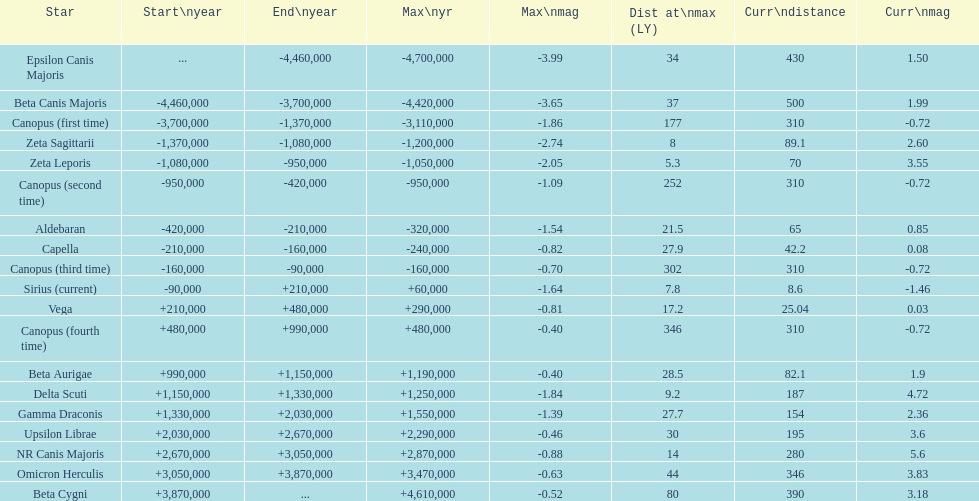Could you parse the entire table as a dict? {'header': ['Star', 'Start\\nyear', 'End\\nyear', 'Max\\nyr', 'Max\\nmag', 'Dist at\\nmax (LY)', 'Curr\\ndistance', 'Curr\\nmag'], 'rows': [['Epsilon Canis Majoris', '...', '-4,460,000', '-4,700,000', '-3.99', '34', '430', '1.50'], ['Beta Canis Majoris', '-4,460,000', '-3,700,000', '-4,420,000', '-3.65', '37', '500', '1.99'], ['Canopus (first time)', '-3,700,000', '-1,370,000', '-3,110,000', '-1.86', '177', '310', '-0.72'], ['Zeta Sagittarii', '-1,370,000', '-1,080,000', '-1,200,000', '-2.74', '8', '89.1', '2.60'], ['Zeta Leporis', '-1,080,000', '-950,000', '-1,050,000', '-2.05', '5.3', '70', '3.55'], ['Canopus (second time)', '-950,000', '-420,000', '-950,000', '-1.09', '252', '310', '-0.72'], ['Aldebaran', '-420,000', '-210,000', '-320,000', '-1.54', '21.5', '65', '0.85'], ['Capella', '-210,000', '-160,000', '-240,000', '-0.82', '27.9', '42.2', '0.08'], ['Canopus (third time)', '-160,000', '-90,000', '-160,000', '-0.70', '302', '310', '-0.72'], ['Sirius (current)', '-90,000', '+210,000', '+60,000', '-1.64', '7.8', '8.6', '-1.46'], ['Vega', '+210,000', '+480,000', '+290,000', '-0.81', '17.2', '25.04', '0.03'], ['Canopus (fourth time)', '+480,000', '+990,000', '+480,000', '-0.40', '346', '310', '-0.72'], ['Beta Aurigae', '+990,000', '+1,150,000', '+1,190,000', '-0.40', '28.5', '82.1', '1.9'], ['Delta Scuti', '+1,150,000', '+1,330,000', '+1,250,000', '-1.84', '9.2', '187', '4.72'], ['Gamma Draconis', '+1,330,000', '+2,030,000', '+1,550,000', '-1.39', '27.7', '154', '2.36'], ['Upsilon Librae', '+2,030,000', '+2,670,000', '+2,290,000', '-0.46', '30', '195', '3.6'], ['NR Canis Majoris', '+2,670,000', '+3,050,000', '+2,870,000', '-0.88', '14', '280', '5.6'], ['Omicron Herculis', '+3,050,000', '+3,870,000', '+3,470,000', '-0.63', '44', '346', '3.83'], ['Beta Cygni', '+3,870,000', '...', '+4,610,000', '-0.52', '80', '390', '3.18']]} How many stars have a current magnitude of at least 1.0? 11. 